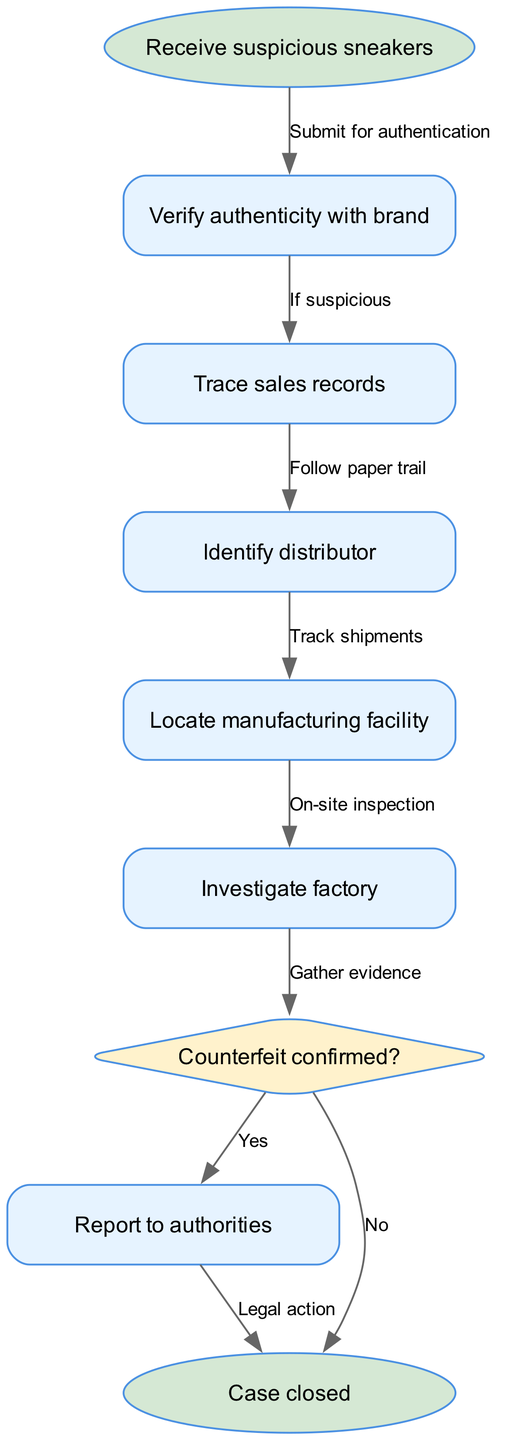What is the first step in the flowchart? The first step in the flowchart is "Receive suspicious sneakers," which is the starting point of the process. The flowchart begins with this node as indicated by its position.
Answer: Receive suspicious sneakers How many nodes are present in the diagram? By counting the entries in the "nodes" section of the data, there are a total of 9 nodes representing different steps in the supply chain tracing process.
Answer: 9 What action is taken after verifying authenticity? After verifying authenticity, the next action taken is to "Trace sales records." This is shown as the next node connected by an edge from the "verify" node, indicating the process continues.
Answer: Trace sales records What decision is made in the flowchart? The flowchart includes a decision node labeled "Counterfeit confirmed?" This node is critical as it directs the flow based on the outcome of the investigation, determining the next steps.
Answer: Counterfeit confirmed? What happens if counterfeit goods are confirmed? If counterfeit goods are confirmed, the flowchart indicates that the next step is to "Report to authorities." This follows from the decision node where 'Yes' leads to reporting, which is necessary to take legal action.
Answer: Report to authorities Which node indicates the end of the process? The end of the process is indicated by the node "Case closed," which is the concluding step in the flowchart. This node signifies that all necessary actions have been completed and no further steps are required.
Answer: Case closed How do you identify the distributor? The flowchart indicates that to identify the distributor, one must "Track shipments" from the distributor node to the factory node, showing the process of linking distributors to specific products.
Answer: Track shipments What node follows the investigation stage? Following the investigation stage, the next node is the "decision" node where the question "Counterfeit confirmed?" is posed, determining the future actions based on the evidence gathered.
Answer: decision What do the edges represent in the flowchart? The edges in the flowchart represent the flow of information or actions between the nodes, essentially connecting one step to the next and indicating the sequence of the process being followed.
Answer: Flow of information 